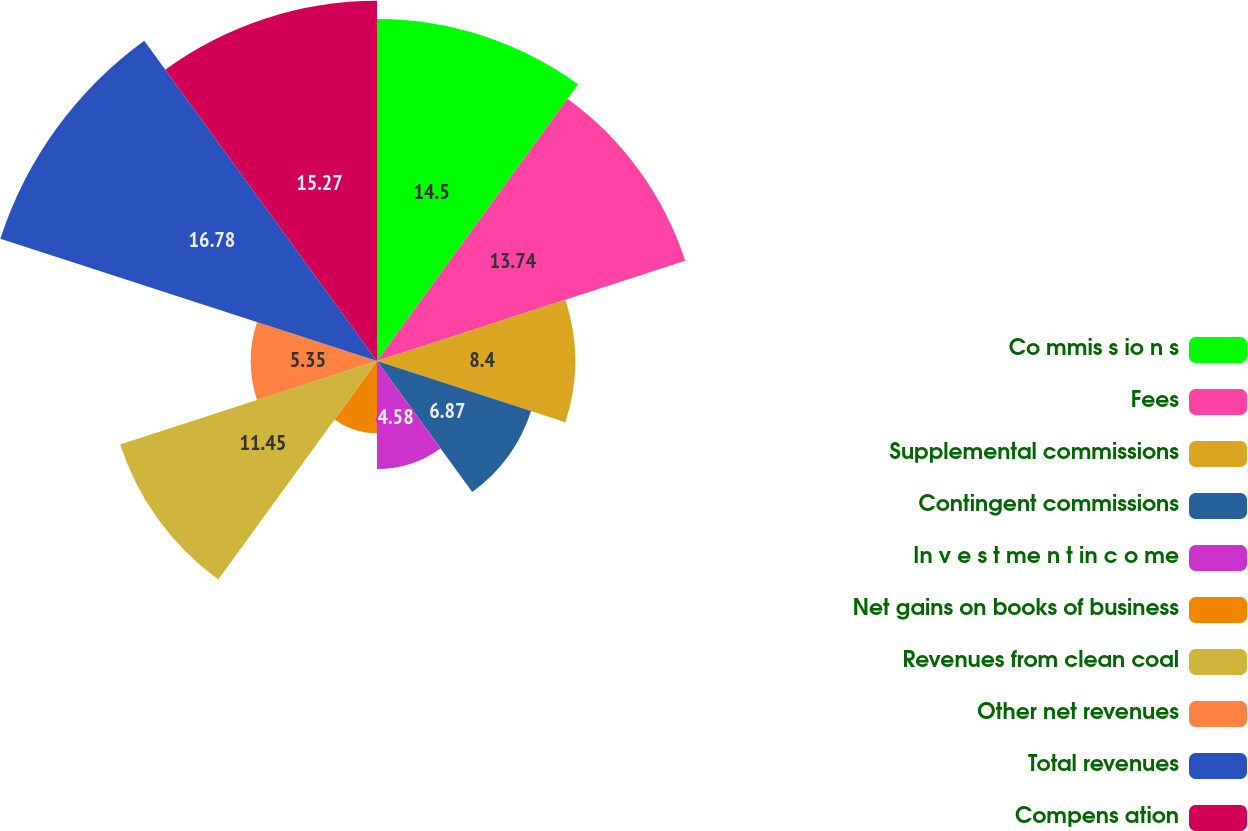Convert chart. <chart><loc_0><loc_0><loc_500><loc_500><pie_chart><fcel>Co mmis s io n s<fcel>Fees<fcel>Supplemental commissions<fcel>Contingent commissions<fcel>In v e s t me n t in c o me<fcel>Net gains on books of business<fcel>Revenues from clean coal<fcel>Other net revenues<fcel>Total revenues<fcel>Compens ation<nl><fcel>14.5%<fcel>13.74%<fcel>8.4%<fcel>6.87%<fcel>4.58%<fcel>3.06%<fcel>11.45%<fcel>5.35%<fcel>16.79%<fcel>15.27%<nl></chart> 